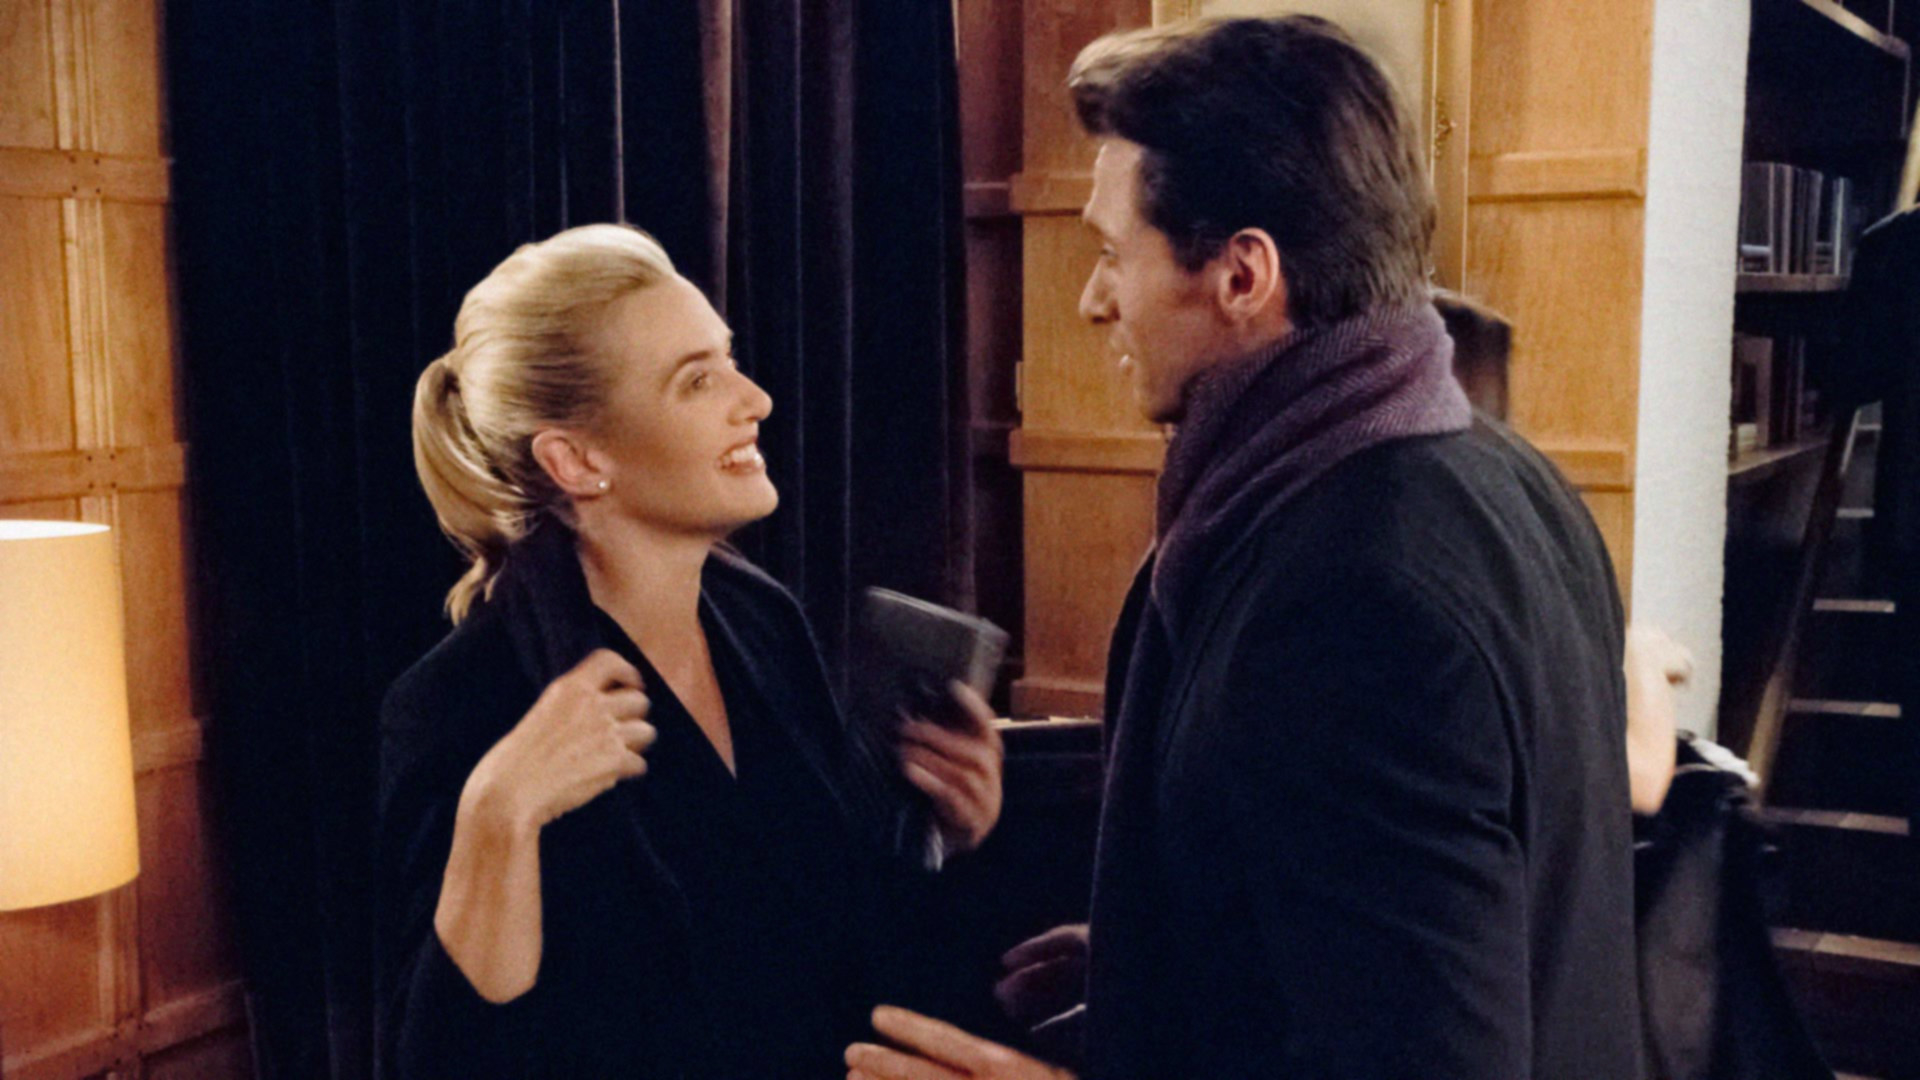Can you tell me more about the setting where these two individuals are? Certainly! The setting appears to be an indoor location with warm lighting. There are bookshelves filled with books, implying a love for literature or a need for research. It could be a private study room or a section of a library, indicated by the organized wooden bookcases and the calm atmosphere suitable for reading or intellectual discussions. 